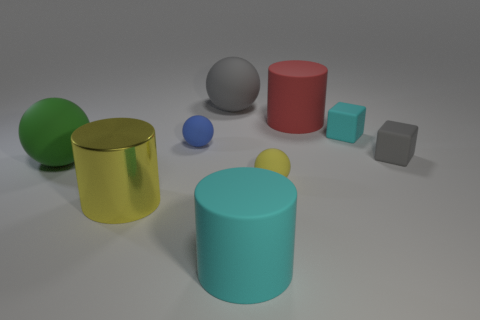There is a cyan matte thing behind the rubber block that is in front of the small cyan matte thing; how many cylinders are on the left side of it? There are no cylinders on the left side of the rubber block. Instead, two cylinders can be seen on the right, with one being green and the other red. On the left, there is only a small blue sphere and a gray cube. 